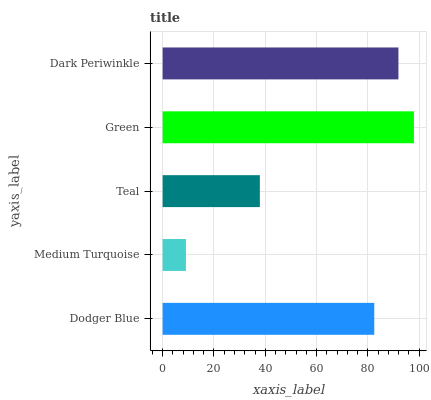Is Medium Turquoise the minimum?
Answer yes or no. Yes. Is Green the maximum?
Answer yes or no. Yes. Is Teal the minimum?
Answer yes or no. No. Is Teal the maximum?
Answer yes or no. No. Is Teal greater than Medium Turquoise?
Answer yes or no. Yes. Is Medium Turquoise less than Teal?
Answer yes or no. Yes. Is Medium Turquoise greater than Teal?
Answer yes or no. No. Is Teal less than Medium Turquoise?
Answer yes or no. No. Is Dodger Blue the high median?
Answer yes or no. Yes. Is Dodger Blue the low median?
Answer yes or no. Yes. Is Medium Turquoise the high median?
Answer yes or no. No. Is Medium Turquoise the low median?
Answer yes or no. No. 